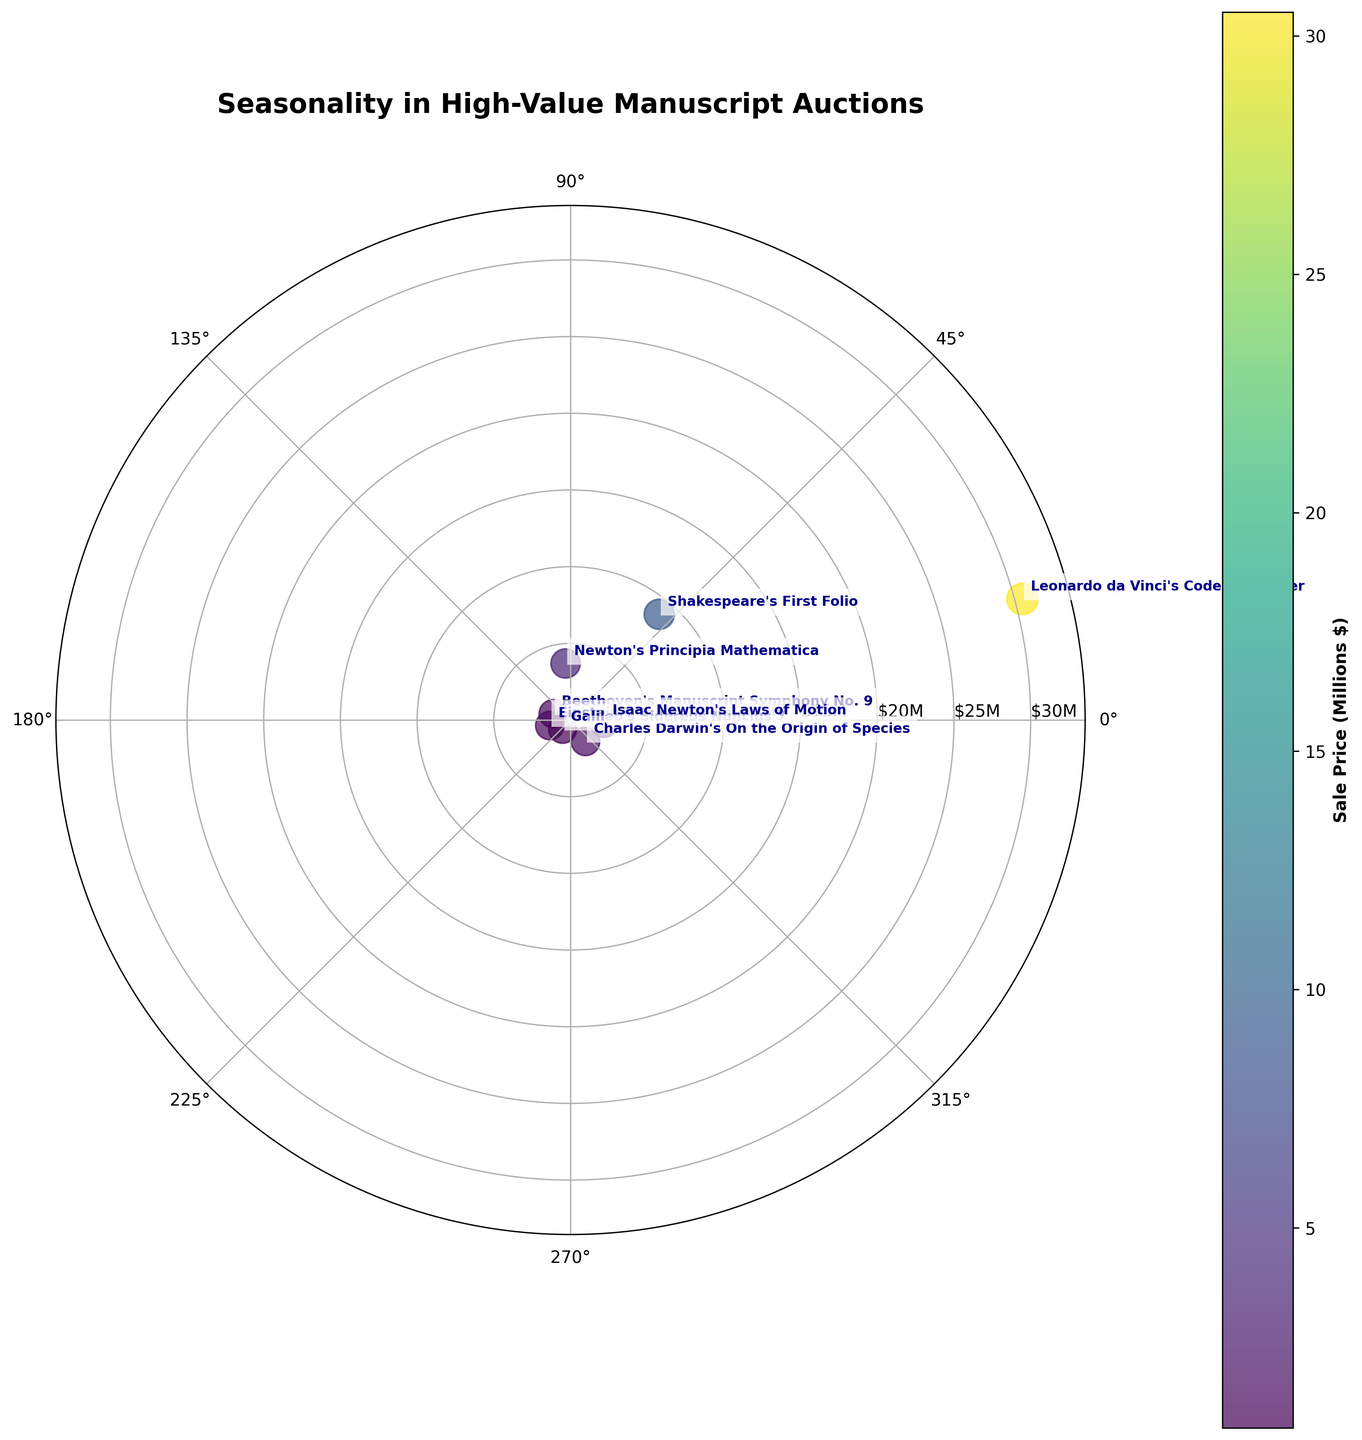What is the title of the figure? The title is usually placed at the top of the figure. From here, it reads "Seasonality in High-Value Manuscript Auctions".
Answer: Seasonality in High-Value Manuscript Auctions How many data points are there on the plot? You can count the number of distinct scatter points in the figure, each representing a manuscript auction. There are eight.
Answer: 8 Which manuscript sold for the highest price, and what was the price? The largest data point corresponds to the highest price. By looking at the annotations and the size, "Leonardo da Vinci's Codex Leicester" is clearly the highest, with a sale price of $30.5M.
Answer: Leonardo da Vinci's Codex Leicester, $30.5M Which manuscript is closest to the center of the chart? The manuscript closest to the center has the smallest radial distance from the origin. "Galileo's Sidereus Nuncius", with a distance of 0.8, fits this criterion.
Answer: Galileo's Sidereus Nuncius In what month did the auction of "Beethoven's Manuscript Symphony No. 9" take place? By converting the compass direction of 160 degrees to the month, this corresponds to June.
Answer: June What is the general trend in manuscript sale prices throughout the year? By observing the sizes (proportional to price) and their distribution around the plot, one can note that higher prices are spread throughout the year without an obvious clustering in any specific period, suggesting no apparent seasonal trend.
Answer: No apparent seasonal trend Is there any clustering of auction events in specific seasons? Looking at the distribution and clustering of points, there's a concentration of events in the winter months around both the beginning and end of the year (e.g., January and December).
Answer: Winter months concentration What is the sale price difference between "Shakespeare's First Folio" and "Newton's Principia Mathematica"? "Shakespeare's First Folio" sold for $9M and "Newton's Principia Mathematica" for $3.7M. The difference is $9M - $3.7M = $5.3M.
Answer: $5.3M Which manuscripts sold for more than $2M? By identifying size and label annotations, "Leonardo da Vinci's Codex Leicester," "Shakespeare's First Folio," and "Isaac Newton's Laws of Motion" all sold for more than $2M.
Answer: Leonardo da Vinci's Codex Leicester, Shakespeare's First Folio, Isaac Newton's Laws of Motion Which direction on the compass has the fewest manuscript sales, and how many manuscripts were sold in that direction? You examine the spread and concentration of points around the compass. The compass directions around the middle of the year (90 to 180 degrees) seem to have the fewest sales, with only two points visible.
Answer: Around 90 to 180 degrees, two manuscripts 